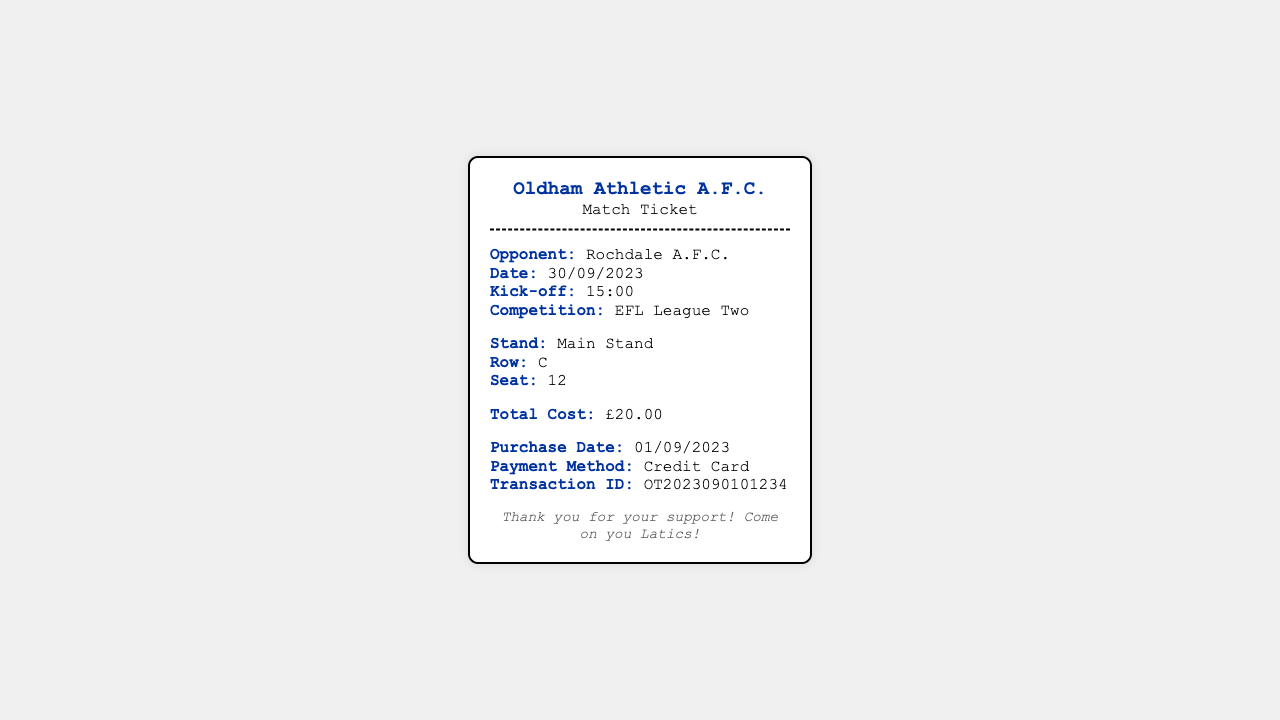What is the total cost of the ticket? The total cost is explicitly stated in the pricing section, which shows £20.00.
Answer: £20.00 What is the opponent's name? The opponent's name is mentioned in the match details section, specifically listed as Rochdale A.F.C.
Answer: Rochdale A.F.C What seating row is indicated? The seating information section specifies that the row is C.
Answer: C When is the match scheduled? The match date is clearly listed in the match details as 30/09/2023.
Answer: 30/09/2023 What is the kick-off time? The kick-off time is provided in the match details and is stated as 15:00.
Answer: 15:00 What stand is the ticket for? The ticket information specifies the stand as the Main Stand in the seating info.
Answer: Main Stand What competition is this match part of? The competition is listed in the match details as EFL League Two.
Answer: EFL League Two What was the payment method? The purchase details state the payment method was Credit Card.
Answer: Credit Card When was the ticket purchased? The purchase date is explicitly mentioned as 01/09/2023 in the purchase details.
Answer: 01/09/2023 